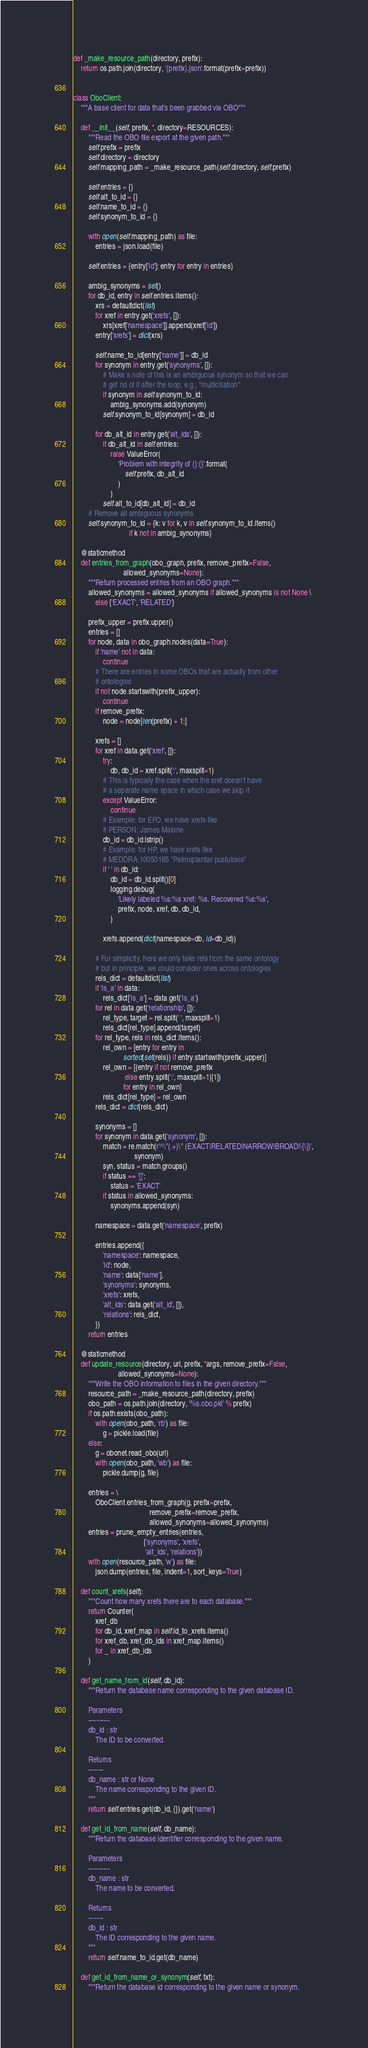<code> <loc_0><loc_0><loc_500><loc_500><_Python_>
def _make_resource_path(directory, prefix):
    return os.path.join(directory, '{prefix}.json'.format(prefix=prefix))


class OboClient:
    """A base client for data that's been grabbed via OBO"""

    def __init__(self, prefix, *, directory=RESOURCES):
        """Read the OBO file export at the given path."""
        self.prefix = prefix
        self.directory = directory
        self.mapping_path = _make_resource_path(self.directory, self.prefix)

        self.entries = {}
        self.alt_to_id = {}
        self.name_to_id = {}
        self.synonym_to_id = {}

        with open(self.mapping_path) as file:
            entries = json.load(file)

        self.entries = {entry['id']: entry for entry in entries}

        ambig_synonyms = set()
        for db_id, entry in self.entries.items():
            xrs = defaultdict(list)
            for xref in entry.get('xrefs', []):
                xrs[xref['namespace']].append(xref['id'])
            entry['xrefs'] = dict(xrs)

            self.name_to_id[entry['name']] = db_id
            for synonym in entry.get('synonyms', []):
                # Make a note of this is an ambiguous synonym so that we can
                # get rid of it after the loop, e.g., "multiciliation"
                if synonym in self.synonym_to_id:
                    ambig_synonyms.add(synonym)
                self.synonym_to_id[synonym] = db_id

            for db_alt_id in entry.get('alt_ids', []):
                if db_alt_id in self.entries:
                    raise ValueError(
                        'Problem with integrity of {}:{}'.format(
                            self.prefix, db_alt_id
                        )
                    )
                self.alt_to_id[db_alt_id] = db_id
        # Remove all ambiguous synonyms
        self.synonym_to_id = {k: v for k, v in self.synonym_to_id.items()
                              if k not in ambig_synonyms}

    @staticmethod
    def entries_from_graph(obo_graph, prefix, remove_prefix=False,
                           allowed_synonyms=None):
        """Return processed entries from an OBO graph."""
        allowed_synonyms = allowed_synonyms if allowed_synonyms is not None \
            else {'EXACT', 'RELATED'}

        prefix_upper = prefix.upper()
        entries = []
        for node, data in obo_graph.nodes(data=True):
            if 'name' not in data:
                continue
            # There are entries in some OBOs that are actually from other
            # ontologies
            if not node.startswith(prefix_upper):
                continue
            if remove_prefix:
                node = node[len(prefix) + 1:]

            xrefs = []
            for xref in data.get('xref', []):
                try:
                    db, db_id = xref.split(':', maxsplit=1)
                # This is typically the case when the xref doesn't have
                # a separate name space in which case we skip it
                except ValueError:
                    continue
                # Example: for EFO, we have xrefs like
                # PERSON: James Malone
                db_id = db_id.lstrip()
                # Example: for HP, we have xrefs like
                # MEDDRA:10050185 "Palmoplantar pustulosis"
                if ' ' in db_id:
                    db_id = db_id.split()[0]
                    logging.debug(
                        'Likely labeled %s:%s xref: %s. Recovered %s:%s',
                        prefix, node, xref, db, db_id,
                    )

                xrefs.append(dict(namespace=db, id=db_id))

            # For simplicity, here we only take rels from the same ontology
            # but in principle, we could consider ones across ontologies
            rels_dict = defaultdict(list)
            if 'is_a' in data:
                rels_dict['is_a'] = data.get('is_a')
            for rel in data.get('relationship', []):
                rel_type, target = rel.split(' ', maxsplit=1)
                rels_dict[rel_type].append(target)
            for rel_type, rels in rels_dict.items():
                rel_own = [entry for entry in
                           sorted(set(rels)) if entry.startswith(prefix_upper)]
                rel_own = [(entry if not remove_prefix
                            else entry.split(':', maxsplit=1)[1])
                           for entry in rel_own]
                rels_dict[rel_type] = rel_own
            rels_dict = dict(rels_dict)

            synonyms = []
            for synonym in data.get('synonym', []):
                match = re.match(r'^\"(.+)\" (EXACT|RELATED|NARROW|BROAD|\[\])',
                                 synonym)
                syn, status = match.groups()
                if status == '[]':
                    status = 'EXACT'
                if status in allowed_synonyms:
                    synonyms.append(syn)

            namespace = data.get('namespace', prefix)

            entries.append({
                'namespace': namespace,
                'id': node,
                'name': data['name'],
                'synonyms': synonyms,
                'xrefs': xrefs,
                'alt_ids': data.get('alt_id', []),
                'relations': rels_dict,
            })
        return entries

    @staticmethod
    def update_resource(directory, url, prefix, *args, remove_prefix=False,
                        allowed_synonyms=None):
        """Write the OBO information to files in the given directory."""
        resource_path = _make_resource_path(directory, prefix)
        obo_path = os.path.join(directory, '%s.obo.pkl' % prefix)
        if os.path.exists(obo_path):
            with open(obo_path, 'rb') as file:
                g = pickle.load(file)
        else:
            g = obonet.read_obo(url)
            with open(obo_path, 'wb') as file:
                pickle.dump(g, file)

        entries = \
            OboClient.entries_from_graph(g, prefix=prefix,
                                         remove_prefix=remove_prefix,
                                         allowed_synonyms=allowed_synonyms)
        entries = prune_empty_entries(entries,
                                      {'synonyms', 'xrefs',
                                       'alt_ids', 'relations'})
        with open(resource_path, 'w') as file:
            json.dump(entries, file, indent=1, sort_keys=True)

    def count_xrefs(self):
        """Count how many xrefs there are to each database."""
        return Counter(
            xref_db
            for db_id, xref_map in self.id_to_xrefs.items()
            for xref_db, xref_db_ids in xref_map.items()
            for _ in xref_db_ids
        )

    def get_name_from_id(self, db_id):
        """Return the database name corresponding to the given database ID.

        Parameters
        ----------
        db_id : str
            The ID to be converted.

        Returns
        -------
        db_name : str or None
            The name corresponding to the given ID.
        """
        return self.entries.get(db_id, {}).get('name')

    def get_id_from_name(self, db_name):
        """Return the database identifier corresponding to the given name.

        Parameters
        ----------
        db_name : str
            The name to be converted.

        Returns
        -------
        db_id : str
            The ID corresponding to the given name.
        """
        return self.name_to_id.get(db_name)

    def get_id_from_name_or_synonym(self, txt):
        """Return the database id corresponding to the given name or synonym.
</code> 